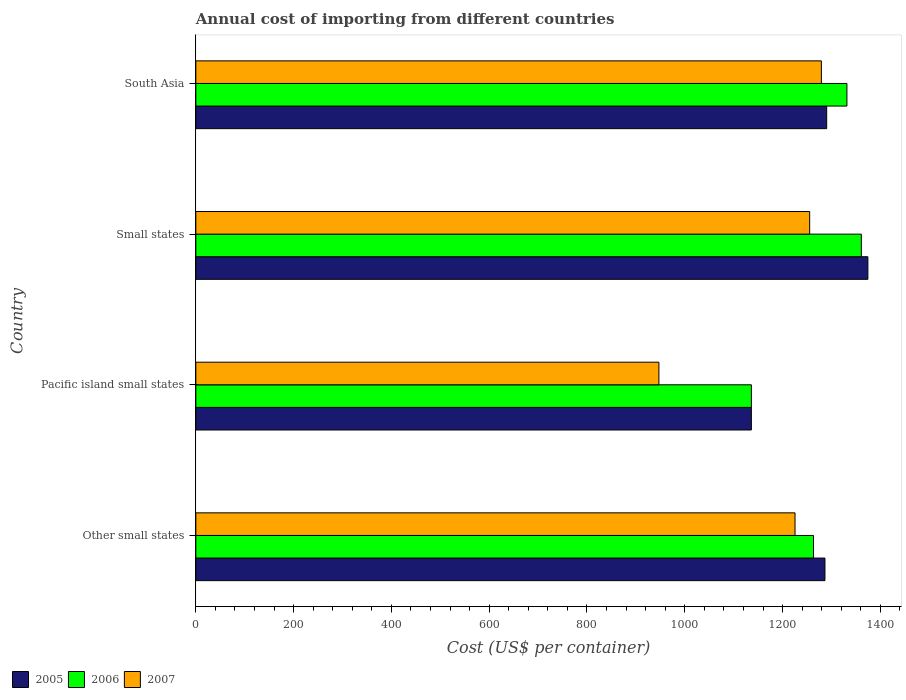How many different coloured bars are there?
Provide a short and direct response. 3. Are the number of bars on each tick of the Y-axis equal?
Your answer should be very brief. Yes. In how many cases, is the number of bars for a given country not equal to the number of legend labels?
Give a very brief answer. 0. What is the total annual cost of importing in 2006 in Small states?
Offer a very short reply. 1361.11. Across all countries, what is the maximum total annual cost of importing in 2005?
Give a very brief answer. 1374.51. Across all countries, what is the minimum total annual cost of importing in 2005?
Your response must be concise. 1136.22. In which country was the total annual cost of importing in 2005 maximum?
Offer a terse response. Small states. In which country was the total annual cost of importing in 2007 minimum?
Offer a terse response. Pacific island small states. What is the total total annual cost of importing in 2005 in the graph?
Your answer should be compact. 5087.69. What is the difference between the total annual cost of importing in 2005 in Other small states and that in South Asia?
Keep it short and to the point. -3.54. What is the difference between the total annual cost of importing in 2006 in Pacific island small states and the total annual cost of importing in 2005 in Small states?
Keep it short and to the point. -238.29. What is the average total annual cost of importing in 2006 per country?
Provide a short and direct response. 1273.06. What is the difference between the total annual cost of importing in 2007 and total annual cost of importing in 2006 in South Asia?
Provide a short and direct response. -52.25. In how many countries, is the total annual cost of importing in 2007 greater than 840 US$?
Provide a succinct answer. 4. What is the ratio of the total annual cost of importing in 2007 in Other small states to that in Pacific island small states?
Offer a very short reply. 1.29. Is the difference between the total annual cost of importing in 2007 in Small states and South Asia greater than the difference between the total annual cost of importing in 2006 in Small states and South Asia?
Provide a succinct answer. No. What is the difference between the highest and the second highest total annual cost of importing in 2006?
Offer a very short reply. 29.48. What is the difference between the highest and the lowest total annual cost of importing in 2005?
Offer a very short reply. 238.29. Is the sum of the total annual cost of importing in 2007 in Pacific island small states and Small states greater than the maximum total annual cost of importing in 2006 across all countries?
Keep it short and to the point. Yes. What does the 3rd bar from the bottom in Pacific island small states represents?
Your answer should be compact. 2007. How many bars are there?
Offer a very short reply. 12. How many countries are there in the graph?
Give a very brief answer. 4. What is the difference between two consecutive major ticks on the X-axis?
Ensure brevity in your answer.  200. Are the values on the major ticks of X-axis written in scientific E-notation?
Your response must be concise. No. Does the graph contain any zero values?
Provide a succinct answer. No. How are the legend labels stacked?
Keep it short and to the point. Horizontal. What is the title of the graph?
Your response must be concise. Annual cost of importing from different countries. What is the label or title of the X-axis?
Your response must be concise. Cost (US$ per container). What is the label or title of the Y-axis?
Offer a very short reply. Country. What is the Cost (US$ per container) in 2005 in Other small states?
Give a very brief answer. 1286.71. What is the Cost (US$ per container) of 2006 in Other small states?
Your answer should be very brief. 1263.28. What is the Cost (US$ per container) in 2007 in Other small states?
Make the answer very short. 1225.5. What is the Cost (US$ per container) of 2005 in Pacific island small states?
Your answer should be compact. 1136.22. What is the Cost (US$ per container) in 2006 in Pacific island small states?
Offer a terse response. 1136.22. What is the Cost (US$ per container) of 2007 in Pacific island small states?
Keep it short and to the point. 947.11. What is the Cost (US$ per container) of 2005 in Small states?
Offer a terse response. 1374.51. What is the Cost (US$ per container) of 2006 in Small states?
Provide a short and direct response. 1361.11. What is the Cost (US$ per container) of 2007 in Small states?
Your answer should be very brief. 1255.44. What is the Cost (US$ per container) in 2005 in South Asia?
Offer a terse response. 1290.25. What is the Cost (US$ per container) in 2006 in South Asia?
Offer a very short reply. 1331.62. What is the Cost (US$ per container) of 2007 in South Asia?
Your answer should be very brief. 1279.38. Across all countries, what is the maximum Cost (US$ per container) in 2005?
Ensure brevity in your answer.  1374.51. Across all countries, what is the maximum Cost (US$ per container) of 2006?
Make the answer very short. 1361.11. Across all countries, what is the maximum Cost (US$ per container) of 2007?
Provide a short and direct response. 1279.38. Across all countries, what is the minimum Cost (US$ per container) of 2005?
Keep it short and to the point. 1136.22. Across all countries, what is the minimum Cost (US$ per container) in 2006?
Give a very brief answer. 1136.22. Across all countries, what is the minimum Cost (US$ per container) of 2007?
Ensure brevity in your answer.  947.11. What is the total Cost (US$ per container) of 2005 in the graph?
Provide a short and direct response. 5087.69. What is the total Cost (US$ per container) in 2006 in the graph?
Offer a terse response. 5092.23. What is the total Cost (US$ per container) in 2007 in the graph?
Provide a succinct answer. 4707.42. What is the difference between the Cost (US$ per container) of 2005 in Other small states and that in Pacific island small states?
Keep it short and to the point. 150.48. What is the difference between the Cost (US$ per container) of 2006 in Other small states and that in Pacific island small states?
Your answer should be very brief. 127.06. What is the difference between the Cost (US$ per container) of 2007 in Other small states and that in Pacific island small states?
Offer a terse response. 278.39. What is the difference between the Cost (US$ per container) of 2005 in Other small states and that in Small states?
Give a very brief answer. -87.81. What is the difference between the Cost (US$ per container) in 2006 in Other small states and that in Small states?
Offer a terse response. -97.83. What is the difference between the Cost (US$ per container) in 2007 in Other small states and that in Small states?
Your response must be concise. -29.94. What is the difference between the Cost (US$ per container) of 2005 in Other small states and that in South Asia?
Offer a terse response. -3.54. What is the difference between the Cost (US$ per container) of 2006 in Other small states and that in South Asia?
Your response must be concise. -68.35. What is the difference between the Cost (US$ per container) in 2007 in Other small states and that in South Asia?
Provide a succinct answer. -53.88. What is the difference between the Cost (US$ per container) of 2005 in Pacific island small states and that in Small states?
Offer a very short reply. -238.29. What is the difference between the Cost (US$ per container) of 2006 in Pacific island small states and that in Small states?
Your answer should be compact. -224.88. What is the difference between the Cost (US$ per container) of 2007 in Pacific island small states and that in Small states?
Ensure brevity in your answer.  -308.32. What is the difference between the Cost (US$ per container) of 2005 in Pacific island small states and that in South Asia?
Offer a very short reply. -154.03. What is the difference between the Cost (US$ per container) of 2006 in Pacific island small states and that in South Asia?
Provide a short and direct response. -195.4. What is the difference between the Cost (US$ per container) of 2007 in Pacific island small states and that in South Asia?
Ensure brevity in your answer.  -332.26. What is the difference between the Cost (US$ per container) of 2005 in Small states and that in South Asia?
Provide a succinct answer. 84.26. What is the difference between the Cost (US$ per container) in 2006 in Small states and that in South Asia?
Give a very brief answer. 29.48. What is the difference between the Cost (US$ per container) of 2007 in Small states and that in South Asia?
Offer a terse response. -23.94. What is the difference between the Cost (US$ per container) in 2005 in Other small states and the Cost (US$ per container) in 2006 in Pacific island small states?
Provide a short and direct response. 150.48. What is the difference between the Cost (US$ per container) of 2005 in Other small states and the Cost (US$ per container) of 2007 in Pacific island small states?
Your answer should be compact. 339.59. What is the difference between the Cost (US$ per container) of 2006 in Other small states and the Cost (US$ per container) of 2007 in Pacific island small states?
Your answer should be very brief. 316.17. What is the difference between the Cost (US$ per container) in 2005 in Other small states and the Cost (US$ per container) in 2006 in Small states?
Give a very brief answer. -74.4. What is the difference between the Cost (US$ per container) of 2005 in Other small states and the Cost (US$ per container) of 2007 in Small states?
Your response must be concise. 31.27. What is the difference between the Cost (US$ per container) in 2006 in Other small states and the Cost (US$ per container) in 2007 in Small states?
Give a very brief answer. 7.84. What is the difference between the Cost (US$ per container) in 2005 in Other small states and the Cost (US$ per container) in 2006 in South Asia?
Offer a very short reply. -44.92. What is the difference between the Cost (US$ per container) of 2005 in Other small states and the Cost (US$ per container) of 2007 in South Asia?
Make the answer very short. 7.33. What is the difference between the Cost (US$ per container) of 2006 in Other small states and the Cost (US$ per container) of 2007 in South Asia?
Make the answer very short. -16.1. What is the difference between the Cost (US$ per container) in 2005 in Pacific island small states and the Cost (US$ per container) in 2006 in Small states?
Offer a very short reply. -224.88. What is the difference between the Cost (US$ per container) in 2005 in Pacific island small states and the Cost (US$ per container) in 2007 in Small states?
Your answer should be compact. -119.21. What is the difference between the Cost (US$ per container) of 2006 in Pacific island small states and the Cost (US$ per container) of 2007 in Small states?
Your response must be concise. -119.21. What is the difference between the Cost (US$ per container) of 2005 in Pacific island small states and the Cost (US$ per container) of 2006 in South Asia?
Give a very brief answer. -195.4. What is the difference between the Cost (US$ per container) of 2005 in Pacific island small states and the Cost (US$ per container) of 2007 in South Asia?
Your answer should be compact. -143.15. What is the difference between the Cost (US$ per container) in 2006 in Pacific island small states and the Cost (US$ per container) in 2007 in South Asia?
Provide a succinct answer. -143.15. What is the difference between the Cost (US$ per container) of 2005 in Small states and the Cost (US$ per container) of 2006 in South Asia?
Offer a very short reply. 42.89. What is the difference between the Cost (US$ per container) of 2005 in Small states and the Cost (US$ per container) of 2007 in South Asia?
Make the answer very short. 95.14. What is the difference between the Cost (US$ per container) of 2006 in Small states and the Cost (US$ per container) of 2007 in South Asia?
Offer a very short reply. 81.73. What is the average Cost (US$ per container) of 2005 per country?
Ensure brevity in your answer.  1271.92. What is the average Cost (US$ per container) of 2006 per country?
Keep it short and to the point. 1273.06. What is the average Cost (US$ per container) of 2007 per country?
Make the answer very short. 1176.86. What is the difference between the Cost (US$ per container) in 2005 and Cost (US$ per container) in 2006 in Other small states?
Offer a very short reply. 23.43. What is the difference between the Cost (US$ per container) of 2005 and Cost (US$ per container) of 2007 in Other small states?
Provide a short and direct response. 61.21. What is the difference between the Cost (US$ per container) of 2006 and Cost (US$ per container) of 2007 in Other small states?
Ensure brevity in your answer.  37.78. What is the difference between the Cost (US$ per container) of 2005 and Cost (US$ per container) of 2007 in Pacific island small states?
Make the answer very short. 189.11. What is the difference between the Cost (US$ per container) of 2006 and Cost (US$ per container) of 2007 in Pacific island small states?
Ensure brevity in your answer.  189.11. What is the difference between the Cost (US$ per container) in 2005 and Cost (US$ per container) in 2006 in Small states?
Your answer should be very brief. 13.41. What is the difference between the Cost (US$ per container) of 2005 and Cost (US$ per container) of 2007 in Small states?
Offer a terse response. 119.08. What is the difference between the Cost (US$ per container) of 2006 and Cost (US$ per container) of 2007 in Small states?
Make the answer very short. 105.67. What is the difference between the Cost (US$ per container) in 2005 and Cost (US$ per container) in 2006 in South Asia?
Ensure brevity in your answer.  -41.38. What is the difference between the Cost (US$ per container) in 2005 and Cost (US$ per container) in 2007 in South Asia?
Your answer should be very brief. 10.88. What is the difference between the Cost (US$ per container) of 2006 and Cost (US$ per container) of 2007 in South Asia?
Give a very brief answer. 52.25. What is the ratio of the Cost (US$ per container) in 2005 in Other small states to that in Pacific island small states?
Your response must be concise. 1.13. What is the ratio of the Cost (US$ per container) of 2006 in Other small states to that in Pacific island small states?
Your answer should be compact. 1.11. What is the ratio of the Cost (US$ per container) in 2007 in Other small states to that in Pacific island small states?
Offer a very short reply. 1.29. What is the ratio of the Cost (US$ per container) of 2005 in Other small states to that in Small states?
Offer a very short reply. 0.94. What is the ratio of the Cost (US$ per container) in 2006 in Other small states to that in Small states?
Offer a terse response. 0.93. What is the ratio of the Cost (US$ per container) of 2007 in Other small states to that in Small states?
Ensure brevity in your answer.  0.98. What is the ratio of the Cost (US$ per container) of 2006 in Other small states to that in South Asia?
Your answer should be very brief. 0.95. What is the ratio of the Cost (US$ per container) of 2007 in Other small states to that in South Asia?
Your response must be concise. 0.96. What is the ratio of the Cost (US$ per container) of 2005 in Pacific island small states to that in Small states?
Provide a succinct answer. 0.83. What is the ratio of the Cost (US$ per container) of 2006 in Pacific island small states to that in Small states?
Provide a short and direct response. 0.83. What is the ratio of the Cost (US$ per container) in 2007 in Pacific island small states to that in Small states?
Make the answer very short. 0.75. What is the ratio of the Cost (US$ per container) of 2005 in Pacific island small states to that in South Asia?
Make the answer very short. 0.88. What is the ratio of the Cost (US$ per container) of 2006 in Pacific island small states to that in South Asia?
Make the answer very short. 0.85. What is the ratio of the Cost (US$ per container) in 2007 in Pacific island small states to that in South Asia?
Your answer should be compact. 0.74. What is the ratio of the Cost (US$ per container) of 2005 in Small states to that in South Asia?
Offer a very short reply. 1.07. What is the ratio of the Cost (US$ per container) of 2006 in Small states to that in South Asia?
Offer a very short reply. 1.02. What is the ratio of the Cost (US$ per container) of 2007 in Small states to that in South Asia?
Ensure brevity in your answer.  0.98. What is the difference between the highest and the second highest Cost (US$ per container) in 2005?
Keep it short and to the point. 84.26. What is the difference between the highest and the second highest Cost (US$ per container) in 2006?
Keep it short and to the point. 29.48. What is the difference between the highest and the second highest Cost (US$ per container) in 2007?
Give a very brief answer. 23.94. What is the difference between the highest and the lowest Cost (US$ per container) of 2005?
Your answer should be compact. 238.29. What is the difference between the highest and the lowest Cost (US$ per container) in 2006?
Ensure brevity in your answer.  224.88. What is the difference between the highest and the lowest Cost (US$ per container) of 2007?
Your answer should be compact. 332.26. 